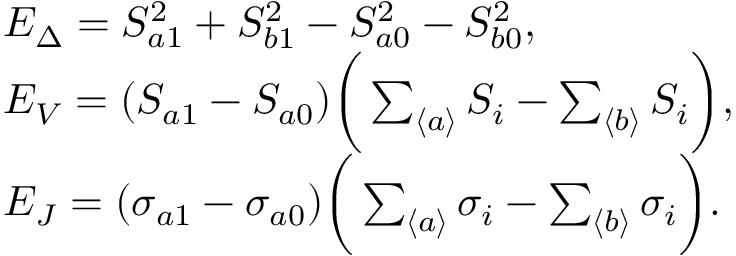Convert formula to latex. <formula><loc_0><loc_0><loc_500><loc_500>\begin{array} { r l } & { E _ { \Delta } = S _ { a 1 } ^ { 2 } + S _ { b 1 } ^ { 2 } - S _ { a 0 } ^ { 2 } - S _ { b 0 } ^ { 2 } , } \\ & { E _ { V } = ( S _ { a 1 } - S _ { a 0 } ) \left ( \sum _ { \langle a \rangle } S _ { i } - \sum _ { \langle b \rangle } S _ { i } \right ) , } \\ & { E _ { J } = ( \sigma _ { a 1 } - \sigma _ { a 0 } ) \left ( \sum _ { \langle a \rangle } \sigma _ { i } - \sum _ { \langle b \rangle } \sigma _ { i } \right ) . } \end{array}</formula> 